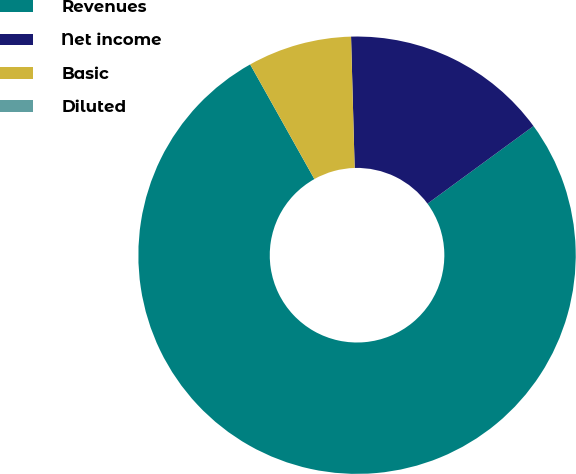Convert chart to OTSL. <chart><loc_0><loc_0><loc_500><loc_500><pie_chart><fcel>Revenues<fcel>Net income<fcel>Basic<fcel>Diluted<nl><fcel>76.92%<fcel>15.38%<fcel>7.69%<fcel>0.0%<nl></chart> 